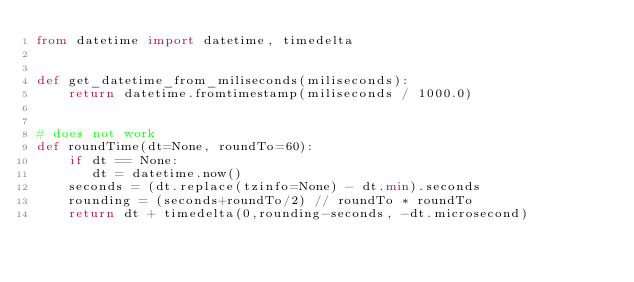Convert code to text. <code><loc_0><loc_0><loc_500><loc_500><_Python_>from datetime import datetime, timedelta


def get_datetime_from_miliseconds(miliseconds):
    return datetime.fromtimestamp(miliseconds / 1000.0)


# does not work
def roundTime(dt=None, roundTo=60):
    if dt == None:
       dt = datetime.now()
    seconds = (dt.replace(tzinfo=None) - dt.min).seconds
    rounding = (seconds+roundTo/2) // roundTo * roundTo
    return dt + timedelta(0,rounding-seconds, -dt.microsecond)
</code> 